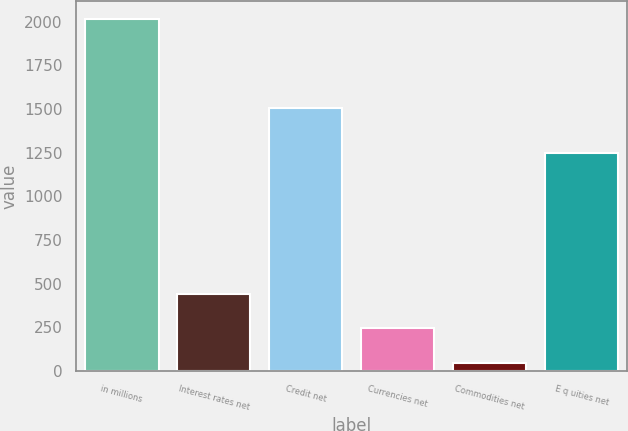Convert chart. <chart><loc_0><loc_0><loc_500><loc_500><bar_chart><fcel>in millions<fcel>Interest rates net<fcel>Credit net<fcel>Currencies net<fcel>Commodities net<fcel>E q uities net<nl><fcel>2017<fcel>441<fcel>1505<fcel>244<fcel>47<fcel>1249<nl></chart> 